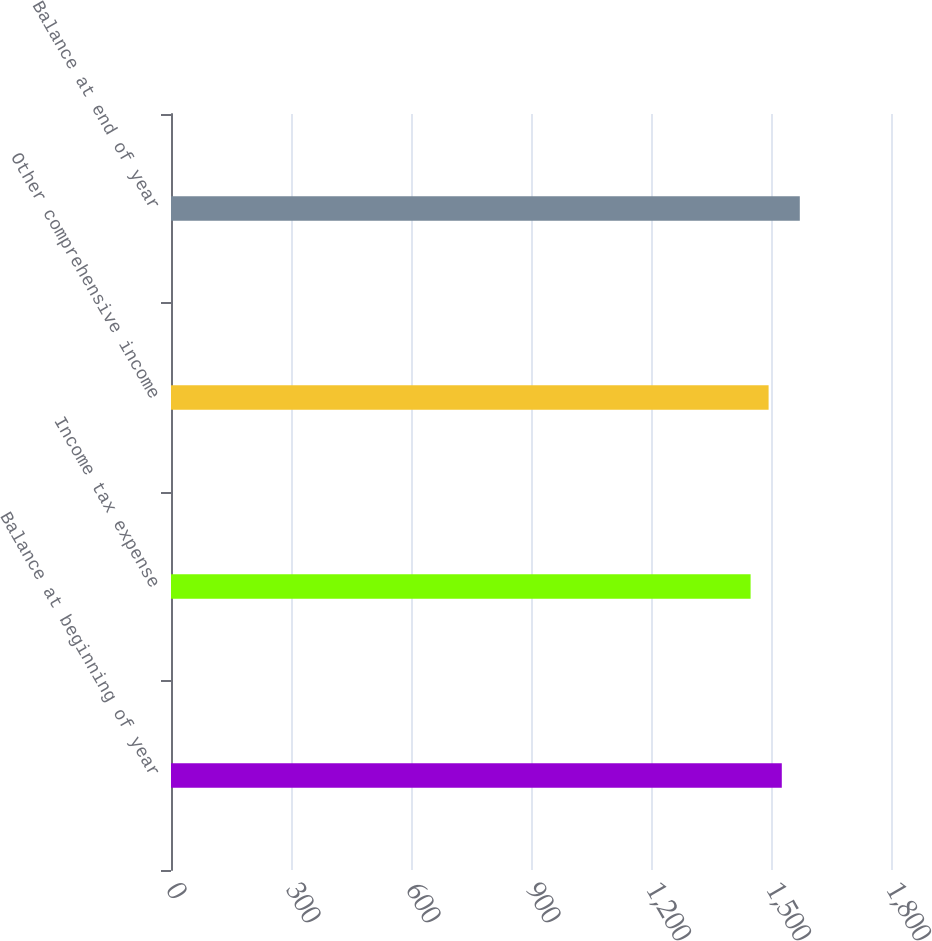<chart> <loc_0><loc_0><loc_500><loc_500><bar_chart><fcel>Balance at beginning of year<fcel>Income tax expense<fcel>Other comprehensive income<fcel>Balance at end of year<nl><fcel>1527<fcel>1449<fcel>1494<fcel>1572<nl></chart> 